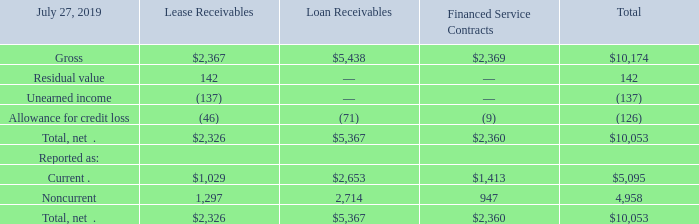8. Financing Receivables and Operating Leases
(a) Financing Receivables
Financing receivables primarily consist of lease receivables, loan receivables, and financed service contracts. Lease receivables represent sales-type and direct-financing leases resulting from the sale of Cisco’s and complementary third-party products and are typically collateralized by a security interest in the underlying assets. Lease receivables consist of arrangements with terms of four years on average. Loan receivables represent financing arrangements related to the sale of our hardware, software, and services, which may include additional funding for other costs associated with network installation and integration of our products and services. Loan receivables have terms of three years on average. Financed service contracts include financing receivables related to technical support and advanced services. Revenue related to the technical support services is typically deferred and included in deferred service revenue and is recognized ratably over the period during which the related services are to be performed, which typically ranges from one to three years.
A summary of our financing receivables is presented as follows (in millions):
What did financing receivables primarily consist of? Lease receivables, loan receivables, and financed service contracts. What did financed service contracts include? Financing receivables related to technical support and advanced services. What was unearned income from lease receivables in 2019?
Answer scale should be: million. (137). What was the difference in the reported total between current and noncurrent financing receivables?
Answer scale should be: million. 5,095-4,958
Answer: 137. What was the difference in the net total between Lease and Loan Receivables?
Answer scale should be: million. 5,367-2,326
Answer: 3041. How many types of financing receivables had a net total that exceeded $5,000 million? Loan Receivables
Answer: 1. 